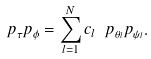Convert formula to latex. <formula><loc_0><loc_0><loc_500><loc_500>p _ { \tau } p _ { \phi } = \sum _ { l = 1 } ^ { N } c _ { l } \ p _ { \theta _ { l } } p _ { \psi _ { l } } .</formula> 